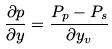<formula> <loc_0><loc_0><loc_500><loc_500>\frac { \partial p } { \partial y } = \frac { P _ { p } - P _ { s } } { \partial y _ { v } }</formula> 